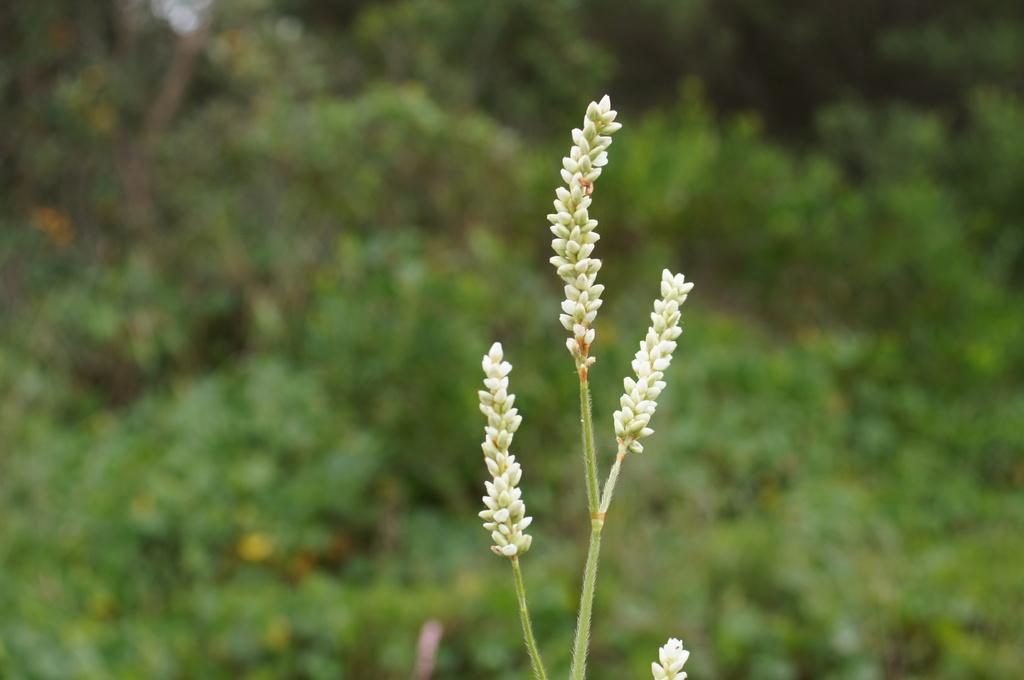What type of flora can be seen in the foreground of the image? There are flowers in the foreground of the image. What type of flora can be seen in the background of the image? There are plants in the background of the image. How does the toothbrush help the flowers in the image? There is no toothbrush present in the image, so it cannot help the flowers. 